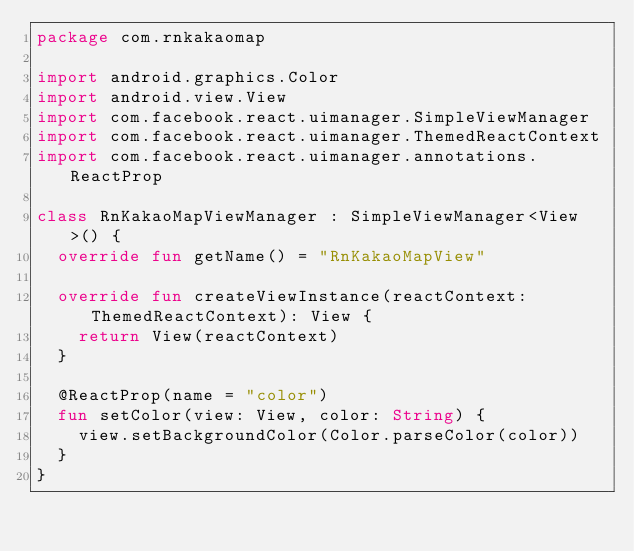Convert code to text. <code><loc_0><loc_0><loc_500><loc_500><_Kotlin_>package com.rnkakaomap

import android.graphics.Color
import android.view.View
import com.facebook.react.uimanager.SimpleViewManager
import com.facebook.react.uimanager.ThemedReactContext
import com.facebook.react.uimanager.annotations.ReactProp

class RnKakaoMapViewManager : SimpleViewManager<View>() {
  override fun getName() = "RnKakaoMapView"

  override fun createViewInstance(reactContext: ThemedReactContext): View {
    return View(reactContext)
  }

  @ReactProp(name = "color")
  fun setColor(view: View, color: String) {
    view.setBackgroundColor(Color.parseColor(color))
  }
}
</code> 